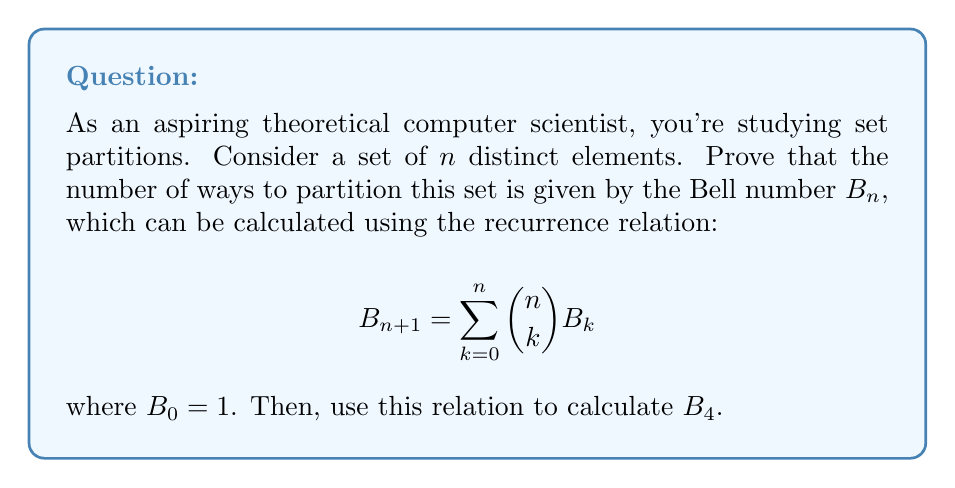Give your solution to this math problem. To prove this recurrence relation and calculate $B_4$, we'll follow these steps:

1) First, let's understand what the recurrence relation means:
   - $B_{n+1}$ is the number of ways to partition a set of $n+1$ elements.
   - $\binom{n}{k}$ is the number of ways to choose $k$ elements from $n$ elements.
   - $B_k$ is the number of ways to partition those $k$ elements.

2) The proof idea:
   - Consider the $(n+1)$-th element in isolation.
   - This element can be in a partition with $k$ other elements, where $k$ can range from 0 to $n$.
   - For each $k$, we choose $k$ elements from the remaining $n$ elements in $\binom{n}{k}$ ways.
   - Those $k$ elements (plus the $(n+1)$-th element) can be partitioned in $B_k$ ways.
   - Sum over all possible $k$ to get the total number of partitions.

3) This reasoning leads directly to the recurrence relation:

   $$B_{n+1} = \sum_{k=0}^n \binom{n}{k} B_k$$

4) Now, let's calculate $B_4$ using this relation:
   - We need $B_0, B_1, B_2,$ and $B_3$ to calculate $B_4$.
   - $B_0 = 1$ (by definition)
   - $B_1 = 1$ (only one way to partition a set with one element)
   - $B_2 = \binom{1}{0}B_0 + \binom{1}{1}B_1 = 1 + 1 = 2$
   - $B_3 = \binom{2}{0}B_0 + \binom{2}{1}B_1 + \binom{2}{2}B_2 = 1 + 2 + 2 = 5$
   - Now we can calculate $B_4$:
     $$B_4 = \binom{3}{0}B_0 + \binom{3}{1}B_1 + \binom{3}{2}B_2 + \binom{3}{3}B_3$$
     $$= 1 \cdot 1 + 3 \cdot 1 + 3 \cdot 2 + 1 \cdot 5 = 15$$

Thus, there are 15 ways to partition a set of 4 distinct elements.
Answer: $B_4 = 15$ 